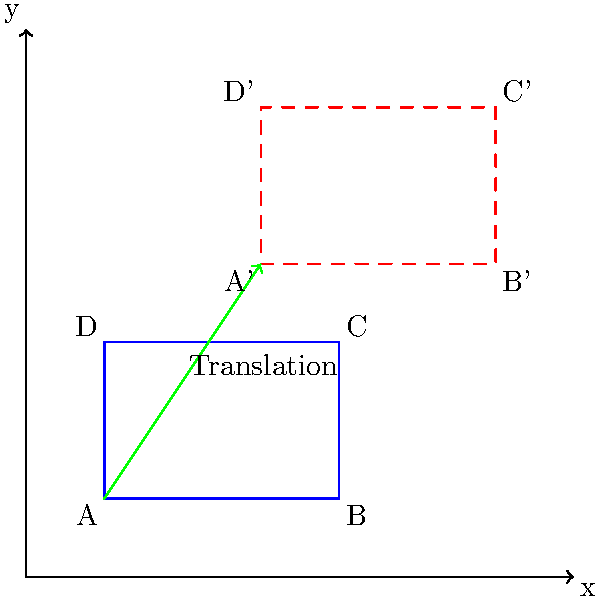Uncle Joey is setting up his comedy club stage for a "Full House" reunion show. The original stage setup is represented by the blue rectangle ABCD on the coordinate plane. Joey wants to move the stage setup to a new location represented by the red dashed rectangle A'B'C'D'. What is the translation vector that moves the original stage setup to its new position? To find the translation vector, we need to determine how far the stage moves horizontally (in the x-direction) and vertically (in the y-direction). We can do this by comparing the coordinates of any corresponding pair of points between the original and translated setups.

Let's use point A (0,0) and its corresponding point A' (2,3):

1. Horizontal movement (x-direction):
   $x_{A'} - x_A = 2 - 0 = 2$ units to the right

2. Vertical movement (y-direction):
   $y_{A'} - y_A = 3 - 0 = 3$ units up

The translation vector is represented by these two movements: 2 units right and 3 units up.

In vector notation, this is written as $\langle 2, 3 \rangle$ or $(2,3)$.

You can verify this by applying the same vector to any other point on the original stage:
- B(3,0) + $\langle 2, 3 \rangle$ = B'(5,3)
- C(3,2) + $\langle 2, 3 \rangle$ = C'(5,5)
- D(0,2) + $\langle 2, 3 \rangle$ = D'(2,5)

Therefore, the translation vector that moves the original stage setup to its new position is $\langle 2, 3 \rangle$.
Answer: $\langle 2, 3 \rangle$ 